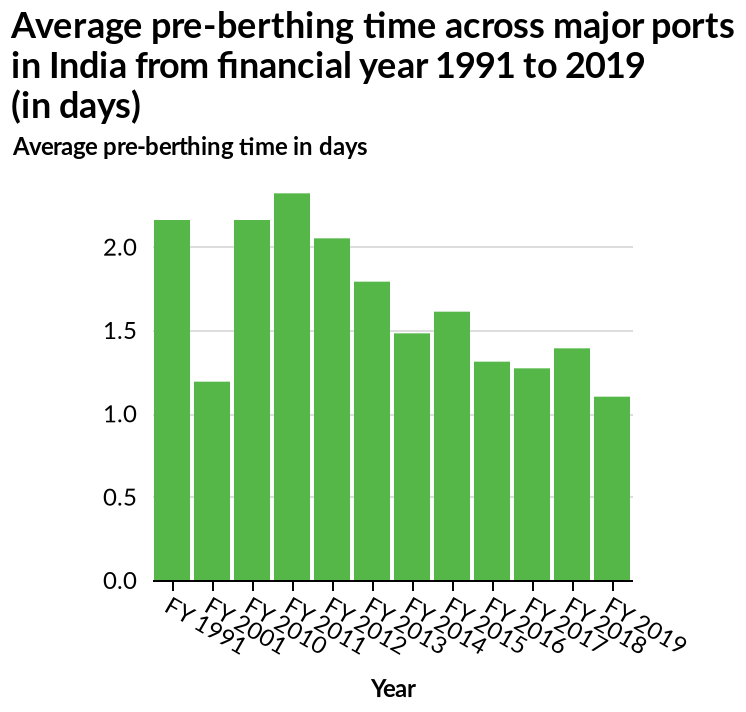<image>
 Was there a significant change in the time of pre berthing in 2001?  Yes, there was a major decrease in the time of pre berthing in 2001. please summary the statistics and relations of the chart As time has progressed, the pre-berthing time of major ports across India has decreased. The only significant exception to this occured in 2001 where it took approx. 1.25 days compared with the average of 2 days. please describe the details of the chart This is a bar chart titled Average pre-berthing time across major ports in India from financial year 1991 to 2019 (in days). There is a categorical scale starting with FY 1991 and ending with FY 2019 along the x-axis, labeled Year. A linear scale from 0.0 to 2.0 can be found on the y-axis, marked Average pre-berthing time in days.  Can you provide a summary of the trend in the time of pre berthing since 2012?  Since 2012, the time of pre berthing has generally decreased with minor spikes in 2015 and 2018. 